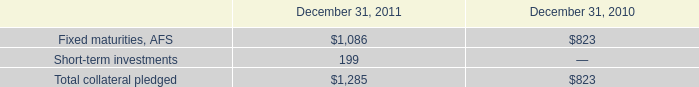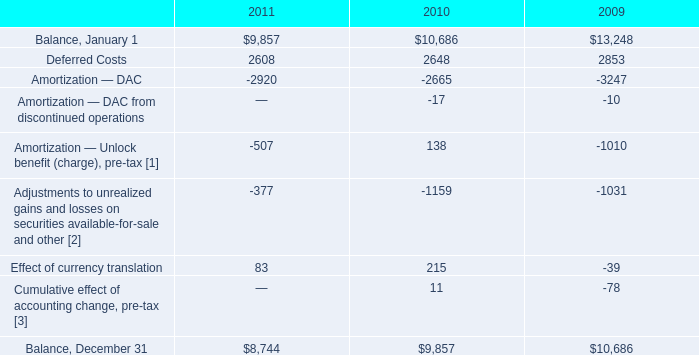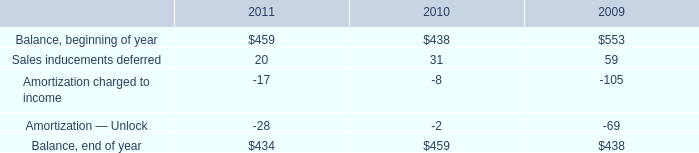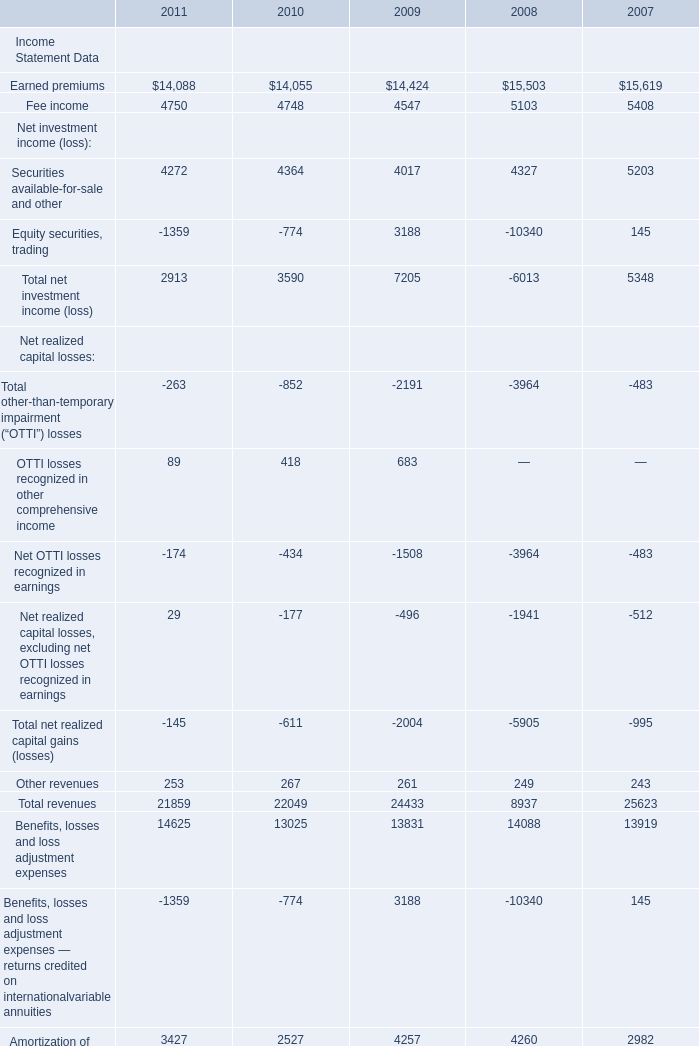What is the average amount of Fixed maturities, AFS of December 31, 2011, and Earned premiums of 2009 ? 
Computations: ((1086.0 + 14424.0) / 2)
Answer: 7755.0. 